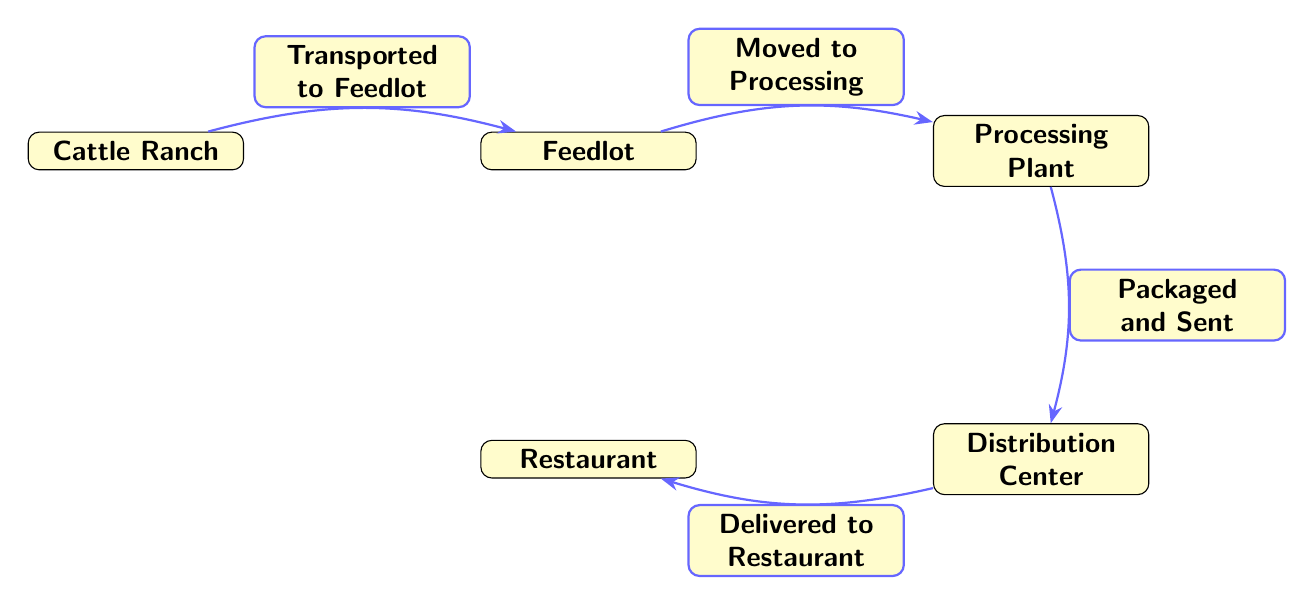What is the first step in the lifecycle of a beef burger? The first step in the lifecycle, as shown in the diagram, is the "Cattle Ranch," where cattle are raised.
Answer: Cattle Ranch How many nodes are in the diagram? By counting the distinct locations in the diagram, we find there are five nodes: Cattle Ranch, Feedlot, Processing Plant, Distribution Center, and Restaurant.
Answer: Five What happens after the cattle are transported to the feedlot? According to the diagram, after the cattle are transported to the feedlot, they are moved to the processing plant.
Answer: Moved to Processing Which node is directly connected to the restaurant? The diagram shows that the "Distribution Center" is the node directly connected to the restaurant, indicating that products are delivered from there.
Answer: Distribution Center What is packaged and sent from the processing plant? The diagram indicates that after processing, beef products are packaged and sent to the distribution center.
Answer: Packaged and Sent How many edges connect all the nodes in the diagram? There are four edges in the diagram, each representing a connection showing the flow from one step to the next in the beef burger lifecycle.
Answer: Four What is the relationship between the distribution center and the restaurant? The diagram indicates that the distribution center delivers products to the restaurant, showing a direct relationship between their roles.
Answer: Delivered to Restaurant What is the last step in the lifecycle? The last step in the lifecycle, according to the diagram, is the "Restaurant," where the final product is served to customers.
Answer: Restaurant What process occurs immediately after the feedlot? The diagram shows that after the feedlot, the cattle are moved to the processing plant, marking the next step.
Answer: Moved to Processing 